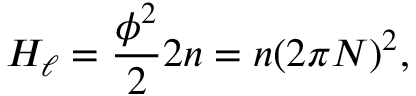<formula> <loc_0><loc_0><loc_500><loc_500>H _ { \ell } = \frac { \phi ^ { 2 } } { 2 } 2 n = n ( 2 \pi N ) ^ { 2 } ,</formula> 